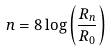Convert formula to latex. <formula><loc_0><loc_0><loc_500><loc_500>n = 8 \log \left ( \frac { R _ { n } } { R _ { 0 } } \right )</formula> 